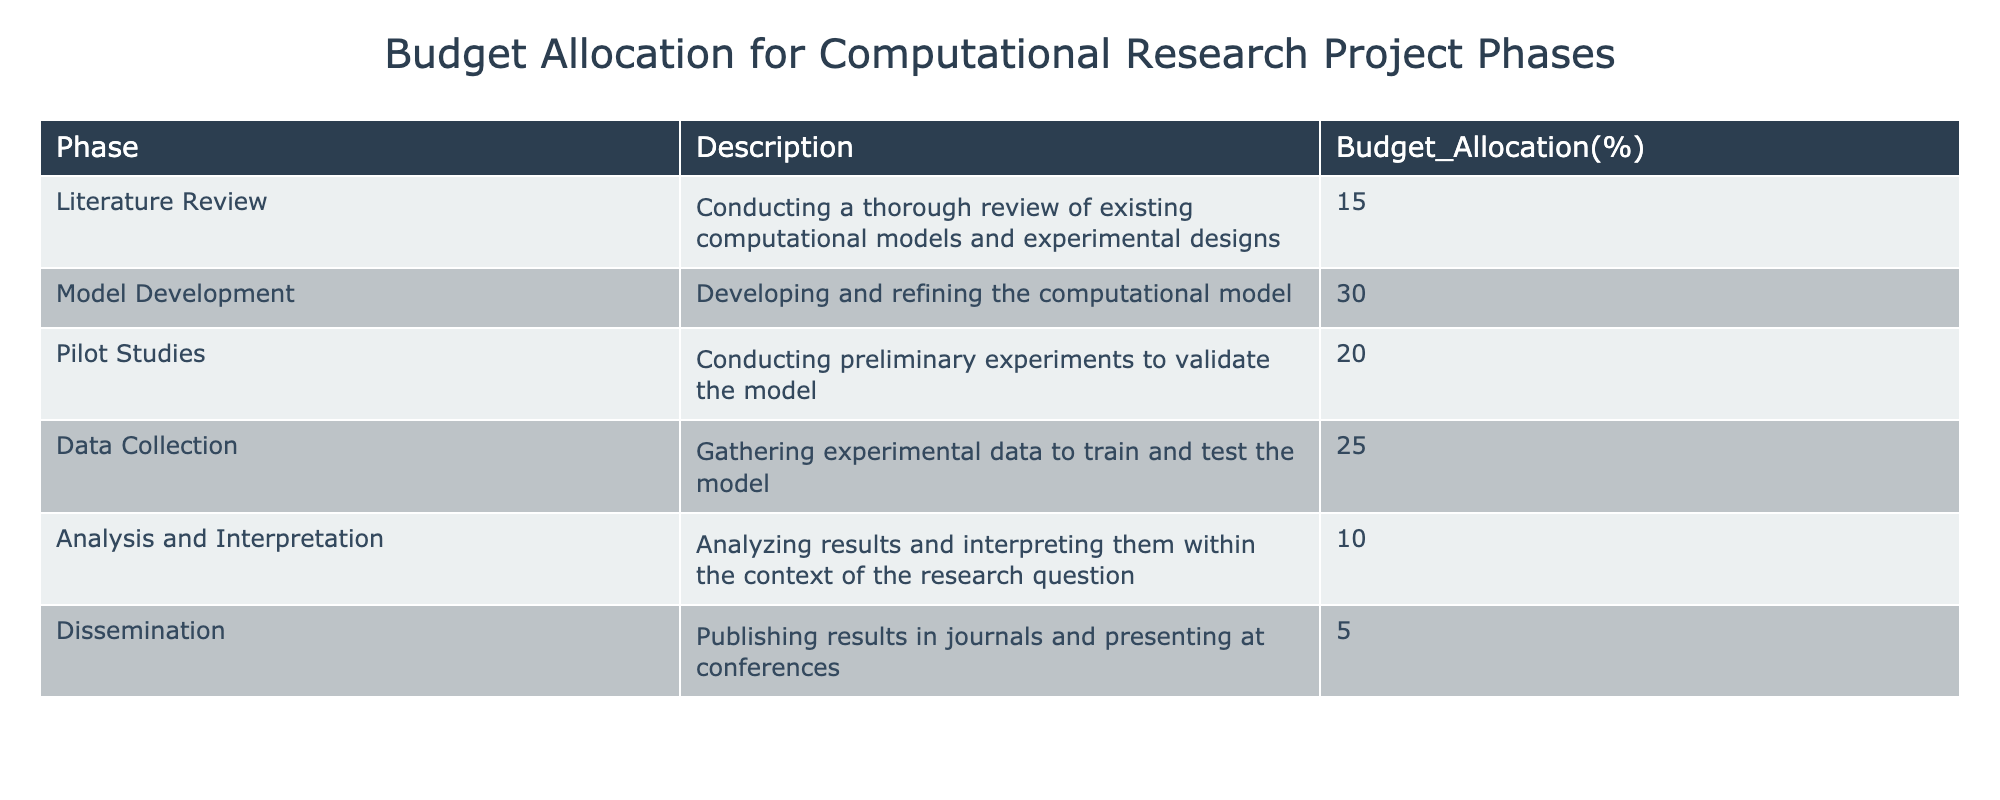What is the budget allocation percentage for Literature Review? The table states that the budget allocation for Literature Review is 15%. This can be located directly under the Budget_Allocation(%) column next to the Literature Review phase.
Answer: 15% What phase has the highest budget allocation? The phase with the highest budget allocation is Model Development at 30%. This is identified by comparing the percentages listed under the Budget_Allocation(%) column.
Answer: Model Development What is the total budget allocation percentage for Pilot Studies and Data Collection combined? By adding the budget allocations for Pilot Studies (20%) and Data Collection (25%), the total is 20 + 25 = 45%. This calculation involves a simple summation of both values.
Answer: 45% Does the budget allocation for Dissemination exceed that of Literature Review? No, the budget allocation for Dissemination is 5%, which is less than Literature Review's allocation of 15%. This fact can be verified by comparing the two corresponding percentages in the table.
Answer: No What percentage decrease occurs from Model Development to Analysis and Interpretation? The budget allocation for Model Development is 30%, and for Analysis and Interpretation, it is 10%. The decrease can be calculated by subtracting 10 from 30, giving us 30 - 10 = 20%. This is a straightforward difference calculation.
Answer: 20% What is the average budget allocation percentage across all phases? To find the average, sum all the budget allocations: 15 + 30 + 20 + 25 + 10 + 5 = 105%. There are 6 phases, so the average is 105% / 6 = 17.5%. This is calculated by dividing the total percentage by the number of phases.
Answer: 17.5% Which phase has the lowest budget allocation? The phase with the lowest budget allocation is Dissemination at 5%. This can be determined by scanning the Budget_Allocation(%) column and identifying the minimum value.
Answer: Dissemination Is the sum of the budget allocations for the first three phases greater than that for the last three phases? Yes, the sum for the first three phases (Literature Review 15% + Model Development 30% + Pilot Studies 20%) equals 65%. The sum for the last three phases (Data Collection 25% + Analysis and Interpretation 10% + Dissemination 5%) equals 40%. Thus, 65% > 40%, meaning the first three phases have a greater sum.
Answer: Yes 